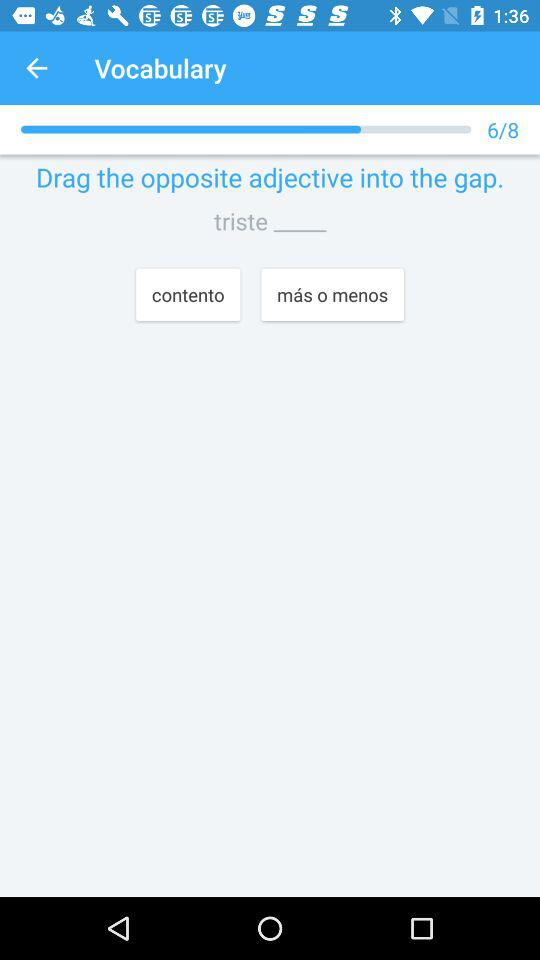How many of the eight questions have been answered? There are 6 questions answered. 